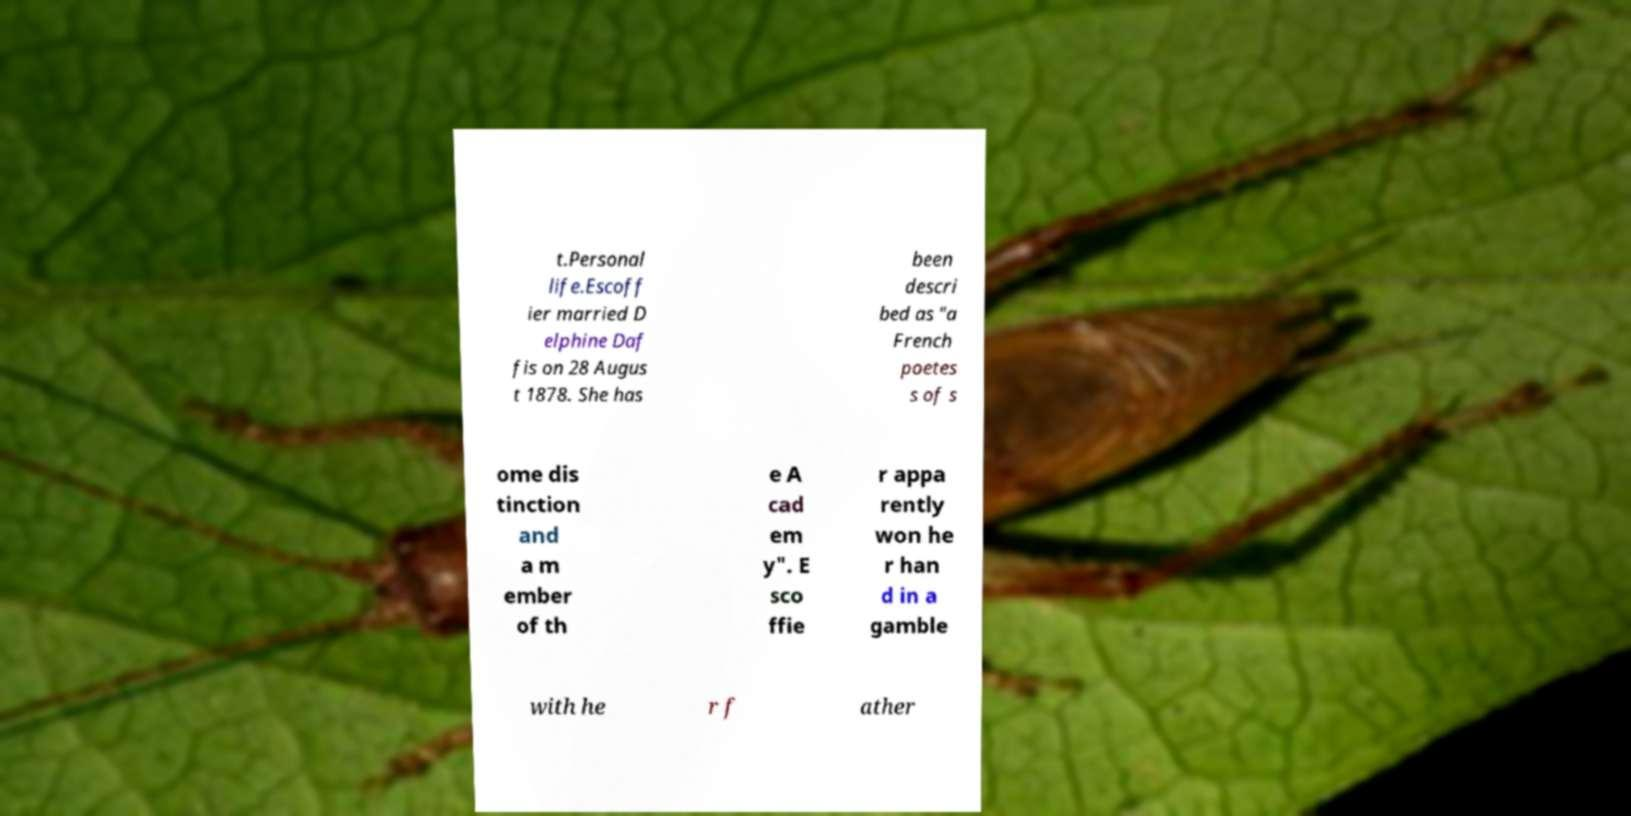For documentation purposes, I need the text within this image transcribed. Could you provide that? t.Personal life.Escoff ier married D elphine Daf fis on 28 Augus t 1878. She has been descri bed as "a French poetes s of s ome dis tinction and a m ember of th e A cad em y". E sco ffie r appa rently won he r han d in a gamble with he r f ather 